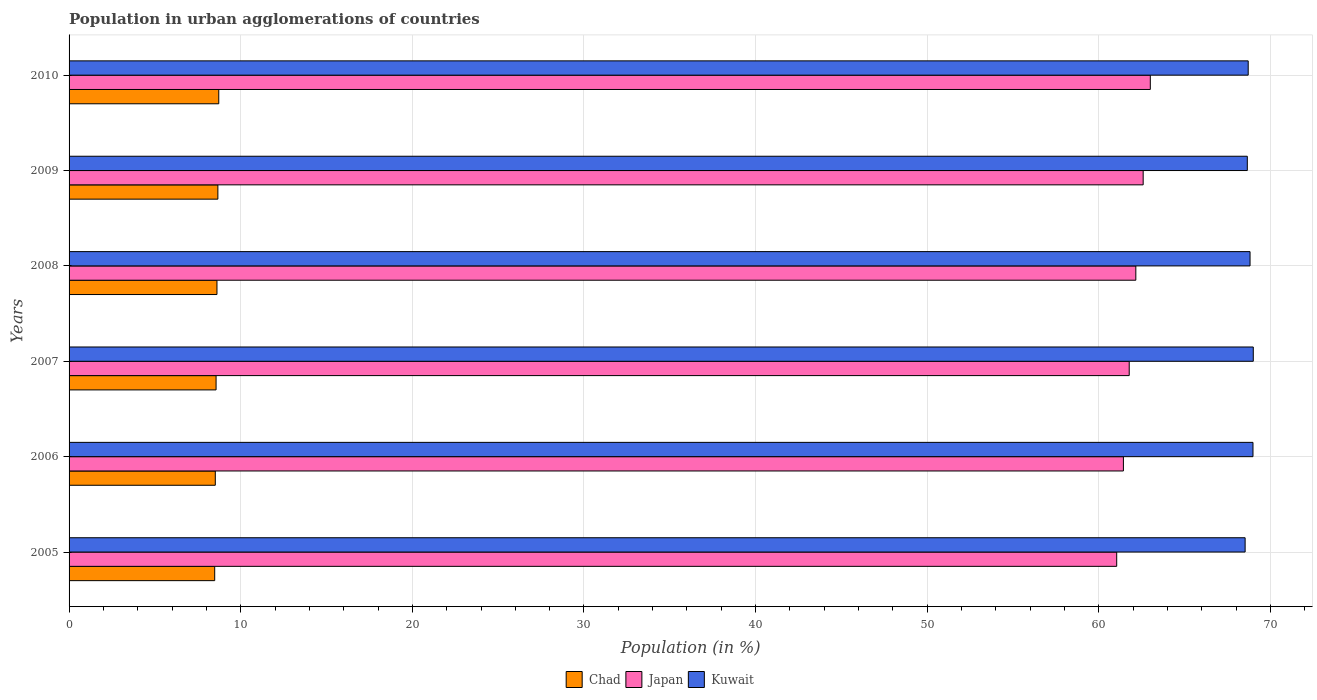How many different coloured bars are there?
Provide a succinct answer. 3. Are the number of bars per tick equal to the number of legend labels?
Provide a succinct answer. Yes. What is the label of the 4th group of bars from the top?
Give a very brief answer. 2007. In how many cases, is the number of bars for a given year not equal to the number of legend labels?
Make the answer very short. 0. What is the percentage of population in urban agglomerations in Kuwait in 2007?
Offer a very short reply. 69. Across all years, what is the maximum percentage of population in urban agglomerations in Kuwait?
Ensure brevity in your answer.  69. Across all years, what is the minimum percentage of population in urban agglomerations in Japan?
Provide a succinct answer. 61.04. In which year was the percentage of population in urban agglomerations in Japan maximum?
Give a very brief answer. 2010. In which year was the percentage of population in urban agglomerations in Japan minimum?
Offer a terse response. 2005. What is the total percentage of population in urban agglomerations in Kuwait in the graph?
Give a very brief answer. 412.65. What is the difference between the percentage of population in urban agglomerations in Kuwait in 2006 and that in 2008?
Make the answer very short. 0.17. What is the difference between the percentage of population in urban agglomerations in Kuwait in 2010 and the percentage of population in urban agglomerations in Chad in 2007?
Keep it short and to the point. 60.13. What is the average percentage of population in urban agglomerations in Kuwait per year?
Your answer should be compact. 68.77. In the year 2010, what is the difference between the percentage of population in urban agglomerations in Kuwait and percentage of population in urban agglomerations in Chad?
Offer a terse response. 59.98. In how many years, is the percentage of population in urban agglomerations in Japan greater than 12 %?
Offer a terse response. 6. What is the ratio of the percentage of population in urban agglomerations in Kuwait in 2008 to that in 2010?
Provide a short and direct response. 1. What is the difference between the highest and the second highest percentage of population in urban agglomerations in Kuwait?
Give a very brief answer. 0.02. What is the difference between the highest and the lowest percentage of population in urban agglomerations in Chad?
Ensure brevity in your answer.  0.24. In how many years, is the percentage of population in urban agglomerations in Japan greater than the average percentage of population in urban agglomerations in Japan taken over all years?
Offer a terse response. 3. What does the 2nd bar from the top in 2008 represents?
Provide a short and direct response. Japan. What does the 2nd bar from the bottom in 2008 represents?
Provide a succinct answer. Japan. What is the difference between two consecutive major ticks on the X-axis?
Offer a very short reply. 10. Are the values on the major ticks of X-axis written in scientific E-notation?
Make the answer very short. No. Where does the legend appear in the graph?
Offer a terse response. Bottom center. How many legend labels are there?
Give a very brief answer. 3. What is the title of the graph?
Provide a succinct answer. Population in urban agglomerations of countries. Does "Swaziland" appear as one of the legend labels in the graph?
Keep it short and to the point. No. What is the Population (in %) in Chad in 2005?
Your answer should be very brief. 8.48. What is the Population (in %) of Japan in 2005?
Offer a very short reply. 61.04. What is the Population (in %) of Kuwait in 2005?
Provide a short and direct response. 68.52. What is the Population (in %) in Chad in 2006?
Offer a very short reply. 8.52. What is the Population (in %) in Japan in 2006?
Your answer should be compact. 61.43. What is the Population (in %) in Kuwait in 2006?
Provide a succinct answer. 68.98. What is the Population (in %) of Chad in 2007?
Keep it short and to the point. 8.57. What is the Population (in %) of Japan in 2007?
Your answer should be compact. 61.77. What is the Population (in %) of Kuwait in 2007?
Provide a succinct answer. 69. What is the Population (in %) of Chad in 2008?
Ensure brevity in your answer.  8.62. What is the Population (in %) of Japan in 2008?
Make the answer very short. 62.15. What is the Population (in %) of Kuwait in 2008?
Your response must be concise. 68.81. What is the Population (in %) in Chad in 2009?
Make the answer very short. 8.67. What is the Population (in %) of Japan in 2009?
Offer a terse response. 62.58. What is the Population (in %) in Kuwait in 2009?
Your answer should be very brief. 68.65. What is the Population (in %) of Chad in 2010?
Your answer should be compact. 8.72. What is the Population (in %) of Japan in 2010?
Your answer should be very brief. 63. What is the Population (in %) in Kuwait in 2010?
Offer a terse response. 68.7. Across all years, what is the maximum Population (in %) in Chad?
Provide a short and direct response. 8.72. Across all years, what is the maximum Population (in %) of Japan?
Offer a terse response. 63. Across all years, what is the maximum Population (in %) in Kuwait?
Provide a short and direct response. 69. Across all years, what is the minimum Population (in %) in Chad?
Provide a succinct answer. 8.48. Across all years, what is the minimum Population (in %) of Japan?
Offer a terse response. 61.04. Across all years, what is the minimum Population (in %) of Kuwait?
Give a very brief answer. 68.52. What is the total Population (in %) of Chad in the graph?
Ensure brevity in your answer.  51.58. What is the total Population (in %) in Japan in the graph?
Keep it short and to the point. 371.96. What is the total Population (in %) of Kuwait in the graph?
Make the answer very short. 412.65. What is the difference between the Population (in %) of Chad in 2005 and that in 2006?
Make the answer very short. -0.04. What is the difference between the Population (in %) in Japan in 2005 and that in 2006?
Ensure brevity in your answer.  -0.39. What is the difference between the Population (in %) of Kuwait in 2005 and that in 2006?
Give a very brief answer. -0.46. What is the difference between the Population (in %) in Chad in 2005 and that in 2007?
Provide a short and direct response. -0.08. What is the difference between the Population (in %) of Japan in 2005 and that in 2007?
Your response must be concise. -0.73. What is the difference between the Population (in %) in Kuwait in 2005 and that in 2007?
Offer a terse response. -0.47. What is the difference between the Population (in %) in Chad in 2005 and that in 2008?
Keep it short and to the point. -0.13. What is the difference between the Population (in %) in Japan in 2005 and that in 2008?
Make the answer very short. -1.11. What is the difference between the Population (in %) of Kuwait in 2005 and that in 2008?
Your response must be concise. -0.29. What is the difference between the Population (in %) in Chad in 2005 and that in 2009?
Provide a succinct answer. -0.19. What is the difference between the Population (in %) of Japan in 2005 and that in 2009?
Ensure brevity in your answer.  -1.54. What is the difference between the Population (in %) of Kuwait in 2005 and that in 2009?
Give a very brief answer. -0.13. What is the difference between the Population (in %) of Chad in 2005 and that in 2010?
Offer a very short reply. -0.24. What is the difference between the Population (in %) of Japan in 2005 and that in 2010?
Your response must be concise. -1.96. What is the difference between the Population (in %) in Kuwait in 2005 and that in 2010?
Offer a terse response. -0.18. What is the difference between the Population (in %) in Chad in 2006 and that in 2007?
Offer a terse response. -0.05. What is the difference between the Population (in %) in Japan in 2006 and that in 2007?
Offer a terse response. -0.34. What is the difference between the Population (in %) in Kuwait in 2006 and that in 2007?
Provide a succinct answer. -0.02. What is the difference between the Population (in %) in Chad in 2006 and that in 2008?
Your response must be concise. -0.1. What is the difference between the Population (in %) in Japan in 2006 and that in 2008?
Offer a very short reply. -0.72. What is the difference between the Population (in %) of Kuwait in 2006 and that in 2008?
Keep it short and to the point. 0.17. What is the difference between the Population (in %) in Chad in 2006 and that in 2009?
Offer a terse response. -0.15. What is the difference between the Population (in %) in Japan in 2006 and that in 2009?
Give a very brief answer. -1.15. What is the difference between the Population (in %) of Kuwait in 2006 and that in 2009?
Ensure brevity in your answer.  0.33. What is the difference between the Population (in %) in Chad in 2006 and that in 2010?
Provide a short and direct response. -0.2. What is the difference between the Population (in %) in Japan in 2006 and that in 2010?
Your response must be concise. -1.57. What is the difference between the Population (in %) in Kuwait in 2006 and that in 2010?
Make the answer very short. 0.28. What is the difference between the Population (in %) of Chad in 2007 and that in 2008?
Provide a short and direct response. -0.05. What is the difference between the Population (in %) of Japan in 2007 and that in 2008?
Provide a short and direct response. -0.39. What is the difference between the Population (in %) of Kuwait in 2007 and that in 2008?
Provide a succinct answer. 0.19. What is the difference between the Population (in %) of Chad in 2007 and that in 2009?
Make the answer very short. -0.1. What is the difference between the Population (in %) of Japan in 2007 and that in 2009?
Your answer should be very brief. -0.81. What is the difference between the Population (in %) in Kuwait in 2007 and that in 2009?
Your answer should be very brief. 0.35. What is the difference between the Population (in %) of Chad in 2007 and that in 2010?
Your response must be concise. -0.16. What is the difference between the Population (in %) of Japan in 2007 and that in 2010?
Offer a terse response. -1.23. What is the difference between the Population (in %) of Kuwait in 2007 and that in 2010?
Give a very brief answer. 0.3. What is the difference between the Population (in %) in Chad in 2008 and that in 2009?
Provide a succinct answer. -0.05. What is the difference between the Population (in %) of Japan in 2008 and that in 2009?
Make the answer very short. -0.43. What is the difference between the Population (in %) in Kuwait in 2008 and that in 2009?
Offer a very short reply. 0.16. What is the difference between the Population (in %) in Chad in 2008 and that in 2010?
Your answer should be very brief. -0.1. What is the difference between the Population (in %) in Japan in 2008 and that in 2010?
Keep it short and to the point. -0.84. What is the difference between the Population (in %) in Kuwait in 2008 and that in 2010?
Make the answer very short. 0.11. What is the difference between the Population (in %) in Chad in 2009 and that in 2010?
Give a very brief answer. -0.05. What is the difference between the Population (in %) in Japan in 2009 and that in 2010?
Ensure brevity in your answer.  -0.42. What is the difference between the Population (in %) of Kuwait in 2009 and that in 2010?
Your response must be concise. -0.05. What is the difference between the Population (in %) in Chad in 2005 and the Population (in %) in Japan in 2006?
Your response must be concise. -52.94. What is the difference between the Population (in %) of Chad in 2005 and the Population (in %) of Kuwait in 2006?
Make the answer very short. -60.49. What is the difference between the Population (in %) of Japan in 2005 and the Population (in %) of Kuwait in 2006?
Ensure brevity in your answer.  -7.94. What is the difference between the Population (in %) of Chad in 2005 and the Population (in %) of Japan in 2007?
Give a very brief answer. -53.28. What is the difference between the Population (in %) of Chad in 2005 and the Population (in %) of Kuwait in 2007?
Make the answer very short. -60.51. What is the difference between the Population (in %) of Japan in 2005 and the Population (in %) of Kuwait in 2007?
Ensure brevity in your answer.  -7.96. What is the difference between the Population (in %) in Chad in 2005 and the Population (in %) in Japan in 2008?
Provide a short and direct response. -53.67. What is the difference between the Population (in %) in Chad in 2005 and the Population (in %) in Kuwait in 2008?
Make the answer very short. -60.32. What is the difference between the Population (in %) in Japan in 2005 and the Population (in %) in Kuwait in 2008?
Offer a very short reply. -7.77. What is the difference between the Population (in %) of Chad in 2005 and the Population (in %) of Japan in 2009?
Your answer should be very brief. -54.1. What is the difference between the Population (in %) of Chad in 2005 and the Population (in %) of Kuwait in 2009?
Keep it short and to the point. -60.16. What is the difference between the Population (in %) of Japan in 2005 and the Population (in %) of Kuwait in 2009?
Offer a terse response. -7.61. What is the difference between the Population (in %) of Chad in 2005 and the Population (in %) of Japan in 2010?
Your answer should be compact. -54.51. What is the difference between the Population (in %) in Chad in 2005 and the Population (in %) in Kuwait in 2010?
Offer a very short reply. -60.22. What is the difference between the Population (in %) in Japan in 2005 and the Population (in %) in Kuwait in 2010?
Your answer should be compact. -7.66. What is the difference between the Population (in %) of Chad in 2006 and the Population (in %) of Japan in 2007?
Keep it short and to the point. -53.25. What is the difference between the Population (in %) of Chad in 2006 and the Population (in %) of Kuwait in 2007?
Your answer should be compact. -60.48. What is the difference between the Population (in %) of Japan in 2006 and the Population (in %) of Kuwait in 2007?
Make the answer very short. -7.57. What is the difference between the Population (in %) in Chad in 2006 and the Population (in %) in Japan in 2008?
Provide a short and direct response. -53.63. What is the difference between the Population (in %) of Chad in 2006 and the Population (in %) of Kuwait in 2008?
Provide a succinct answer. -60.29. What is the difference between the Population (in %) in Japan in 2006 and the Population (in %) in Kuwait in 2008?
Make the answer very short. -7.38. What is the difference between the Population (in %) in Chad in 2006 and the Population (in %) in Japan in 2009?
Give a very brief answer. -54.06. What is the difference between the Population (in %) of Chad in 2006 and the Population (in %) of Kuwait in 2009?
Offer a very short reply. -60.13. What is the difference between the Population (in %) in Japan in 2006 and the Population (in %) in Kuwait in 2009?
Offer a very short reply. -7.22. What is the difference between the Population (in %) in Chad in 2006 and the Population (in %) in Japan in 2010?
Offer a very short reply. -54.48. What is the difference between the Population (in %) in Chad in 2006 and the Population (in %) in Kuwait in 2010?
Ensure brevity in your answer.  -60.18. What is the difference between the Population (in %) of Japan in 2006 and the Population (in %) of Kuwait in 2010?
Your answer should be very brief. -7.27. What is the difference between the Population (in %) in Chad in 2007 and the Population (in %) in Japan in 2008?
Offer a terse response. -53.59. What is the difference between the Population (in %) of Chad in 2007 and the Population (in %) of Kuwait in 2008?
Your response must be concise. -60.24. What is the difference between the Population (in %) of Japan in 2007 and the Population (in %) of Kuwait in 2008?
Provide a succinct answer. -7.04. What is the difference between the Population (in %) of Chad in 2007 and the Population (in %) of Japan in 2009?
Your answer should be very brief. -54.01. What is the difference between the Population (in %) of Chad in 2007 and the Population (in %) of Kuwait in 2009?
Provide a short and direct response. -60.08. What is the difference between the Population (in %) of Japan in 2007 and the Population (in %) of Kuwait in 2009?
Offer a terse response. -6.88. What is the difference between the Population (in %) in Chad in 2007 and the Population (in %) in Japan in 2010?
Your answer should be very brief. -54.43. What is the difference between the Population (in %) in Chad in 2007 and the Population (in %) in Kuwait in 2010?
Keep it short and to the point. -60.13. What is the difference between the Population (in %) of Japan in 2007 and the Population (in %) of Kuwait in 2010?
Give a very brief answer. -6.93. What is the difference between the Population (in %) in Chad in 2008 and the Population (in %) in Japan in 2009?
Keep it short and to the point. -53.96. What is the difference between the Population (in %) of Chad in 2008 and the Population (in %) of Kuwait in 2009?
Make the answer very short. -60.03. What is the difference between the Population (in %) of Japan in 2008 and the Population (in %) of Kuwait in 2009?
Your answer should be very brief. -6.5. What is the difference between the Population (in %) in Chad in 2008 and the Population (in %) in Japan in 2010?
Your answer should be compact. -54.38. What is the difference between the Population (in %) in Chad in 2008 and the Population (in %) in Kuwait in 2010?
Make the answer very short. -60.08. What is the difference between the Population (in %) in Japan in 2008 and the Population (in %) in Kuwait in 2010?
Keep it short and to the point. -6.55. What is the difference between the Population (in %) of Chad in 2009 and the Population (in %) of Japan in 2010?
Your answer should be very brief. -54.33. What is the difference between the Population (in %) in Chad in 2009 and the Population (in %) in Kuwait in 2010?
Make the answer very short. -60.03. What is the difference between the Population (in %) of Japan in 2009 and the Population (in %) of Kuwait in 2010?
Your answer should be very brief. -6.12. What is the average Population (in %) of Chad per year?
Your answer should be compact. 8.6. What is the average Population (in %) of Japan per year?
Your answer should be very brief. 61.99. What is the average Population (in %) of Kuwait per year?
Your answer should be compact. 68.77. In the year 2005, what is the difference between the Population (in %) in Chad and Population (in %) in Japan?
Provide a succinct answer. -52.55. In the year 2005, what is the difference between the Population (in %) in Chad and Population (in %) in Kuwait?
Your response must be concise. -60.04. In the year 2005, what is the difference between the Population (in %) of Japan and Population (in %) of Kuwait?
Keep it short and to the point. -7.48. In the year 2006, what is the difference between the Population (in %) in Chad and Population (in %) in Japan?
Your response must be concise. -52.91. In the year 2006, what is the difference between the Population (in %) in Chad and Population (in %) in Kuwait?
Your answer should be compact. -60.46. In the year 2006, what is the difference between the Population (in %) in Japan and Population (in %) in Kuwait?
Your response must be concise. -7.55. In the year 2007, what is the difference between the Population (in %) in Chad and Population (in %) in Japan?
Your response must be concise. -53.2. In the year 2007, what is the difference between the Population (in %) of Chad and Population (in %) of Kuwait?
Your answer should be very brief. -60.43. In the year 2007, what is the difference between the Population (in %) of Japan and Population (in %) of Kuwait?
Provide a short and direct response. -7.23. In the year 2008, what is the difference between the Population (in %) of Chad and Population (in %) of Japan?
Provide a succinct answer. -53.53. In the year 2008, what is the difference between the Population (in %) of Chad and Population (in %) of Kuwait?
Make the answer very short. -60.19. In the year 2008, what is the difference between the Population (in %) in Japan and Population (in %) in Kuwait?
Your response must be concise. -6.66. In the year 2009, what is the difference between the Population (in %) of Chad and Population (in %) of Japan?
Your response must be concise. -53.91. In the year 2009, what is the difference between the Population (in %) in Chad and Population (in %) in Kuwait?
Give a very brief answer. -59.98. In the year 2009, what is the difference between the Population (in %) of Japan and Population (in %) of Kuwait?
Give a very brief answer. -6.07. In the year 2010, what is the difference between the Population (in %) of Chad and Population (in %) of Japan?
Your answer should be compact. -54.27. In the year 2010, what is the difference between the Population (in %) in Chad and Population (in %) in Kuwait?
Your answer should be very brief. -59.98. In the year 2010, what is the difference between the Population (in %) in Japan and Population (in %) in Kuwait?
Ensure brevity in your answer.  -5.7. What is the ratio of the Population (in %) in Japan in 2005 to that in 2006?
Give a very brief answer. 0.99. What is the ratio of the Population (in %) in Chad in 2005 to that in 2007?
Offer a very short reply. 0.99. What is the ratio of the Population (in %) of Kuwait in 2005 to that in 2007?
Your answer should be compact. 0.99. What is the ratio of the Population (in %) in Chad in 2005 to that in 2008?
Your response must be concise. 0.98. What is the ratio of the Population (in %) of Japan in 2005 to that in 2008?
Offer a terse response. 0.98. What is the ratio of the Population (in %) in Kuwait in 2005 to that in 2008?
Make the answer very short. 1. What is the ratio of the Population (in %) of Chad in 2005 to that in 2009?
Keep it short and to the point. 0.98. What is the ratio of the Population (in %) in Japan in 2005 to that in 2009?
Your answer should be very brief. 0.98. What is the ratio of the Population (in %) of Chad in 2005 to that in 2010?
Ensure brevity in your answer.  0.97. What is the ratio of the Population (in %) of Japan in 2005 to that in 2010?
Your answer should be compact. 0.97. What is the ratio of the Population (in %) of Japan in 2006 to that in 2007?
Ensure brevity in your answer.  0.99. What is the ratio of the Population (in %) of Kuwait in 2006 to that in 2007?
Offer a terse response. 1. What is the ratio of the Population (in %) in Chad in 2006 to that in 2008?
Provide a succinct answer. 0.99. What is the ratio of the Population (in %) in Japan in 2006 to that in 2008?
Provide a short and direct response. 0.99. What is the ratio of the Population (in %) in Chad in 2006 to that in 2009?
Provide a short and direct response. 0.98. What is the ratio of the Population (in %) of Japan in 2006 to that in 2009?
Provide a short and direct response. 0.98. What is the ratio of the Population (in %) of Kuwait in 2006 to that in 2009?
Provide a succinct answer. 1. What is the ratio of the Population (in %) in Chad in 2006 to that in 2010?
Make the answer very short. 0.98. What is the ratio of the Population (in %) of Japan in 2006 to that in 2010?
Provide a short and direct response. 0.98. What is the ratio of the Population (in %) of Chad in 2007 to that in 2008?
Make the answer very short. 0.99. What is the ratio of the Population (in %) of Japan in 2007 to that in 2008?
Your answer should be very brief. 0.99. What is the ratio of the Population (in %) in Kuwait in 2007 to that in 2008?
Offer a terse response. 1. What is the ratio of the Population (in %) of Chad in 2007 to that in 2009?
Your answer should be very brief. 0.99. What is the ratio of the Population (in %) in Kuwait in 2007 to that in 2009?
Your response must be concise. 1.01. What is the ratio of the Population (in %) in Chad in 2007 to that in 2010?
Keep it short and to the point. 0.98. What is the ratio of the Population (in %) in Japan in 2007 to that in 2010?
Your answer should be compact. 0.98. What is the ratio of the Population (in %) in Chad in 2008 to that in 2009?
Offer a terse response. 0.99. What is the ratio of the Population (in %) in Kuwait in 2008 to that in 2009?
Make the answer very short. 1. What is the ratio of the Population (in %) of Chad in 2008 to that in 2010?
Offer a terse response. 0.99. What is the ratio of the Population (in %) of Japan in 2008 to that in 2010?
Give a very brief answer. 0.99. What is the ratio of the Population (in %) of Kuwait in 2008 to that in 2010?
Provide a short and direct response. 1. What is the ratio of the Population (in %) of Chad in 2009 to that in 2010?
Offer a terse response. 0.99. What is the difference between the highest and the second highest Population (in %) of Chad?
Offer a very short reply. 0.05. What is the difference between the highest and the second highest Population (in %) of Japan?
Give a very brief answer. 0.42. What is the difference between the highest and the second highest Population (in %) of Kuwait?
Your response must be concise. 0.02. What is the difference between the highest and the lowest Population (in %) of Chad?
Provide a succinct answer. 0.24. What is the difference between the highest and the lowest Population (in %) of Japan?
Give a very brief answer. 1.96. What is the difference between the highest and the lowest Population (in %) in Kuwait?
Offer a very short reply. 0.47. 